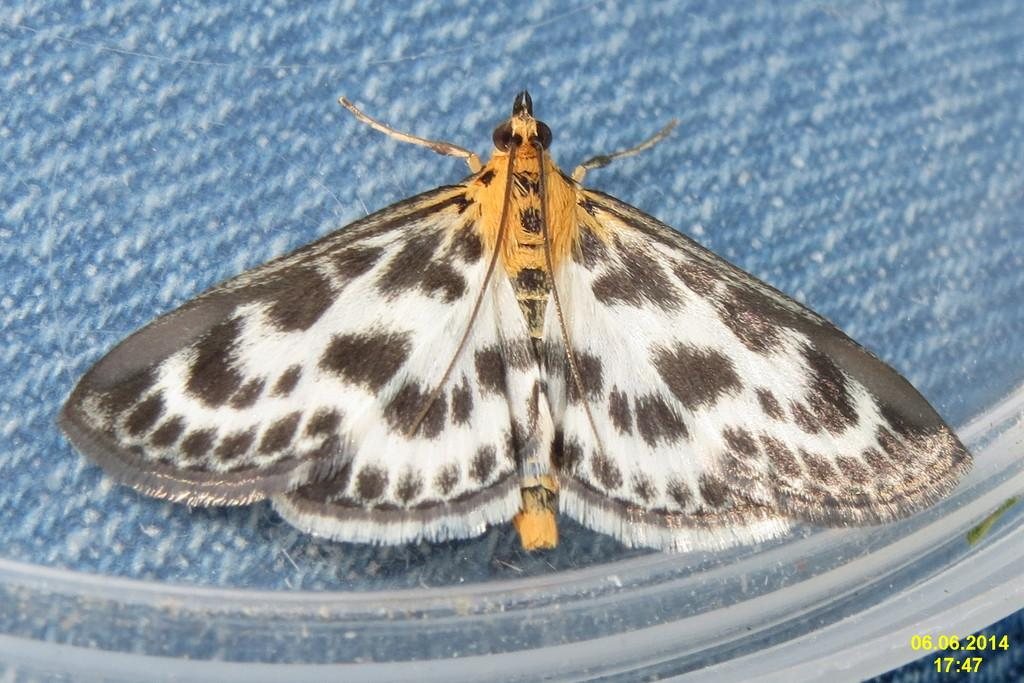What is the main subject in the middle of the image? There is a butterfly in the middle of the image. Where can the numbers be found in the image? The numbers are in the bottom right-hand side of the image. What type of shoe is the butterfly wearing in the image? There is no shoe present in the image, as the main subject is a butterfly, which does not wear shoes. 